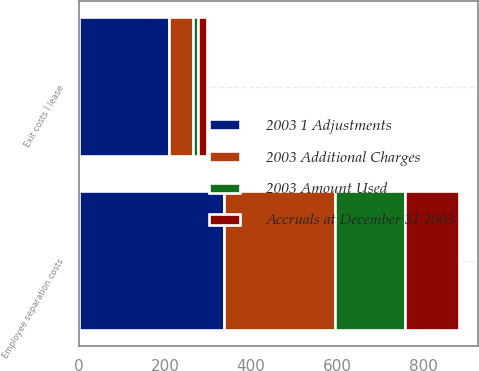Convert chart to OTSL. <chart><loc_0><loc_0><loc_500><loc_500><stacked_bar_chart><ecel><fcel>Exit costs Ì lease<fcel>Employee separation costs<nl><fcel>2003 1 Adjustments<fcel>209<fcel>336<nl><fcel>2003 Amount Used<fcel>11<fcel>163<nl><fcel>Accruals at December 31 2003<fcel>20<fcel>125<nl><fcel>2003 Additional Charges<fcel>57<fcel>258<nl></chart> 